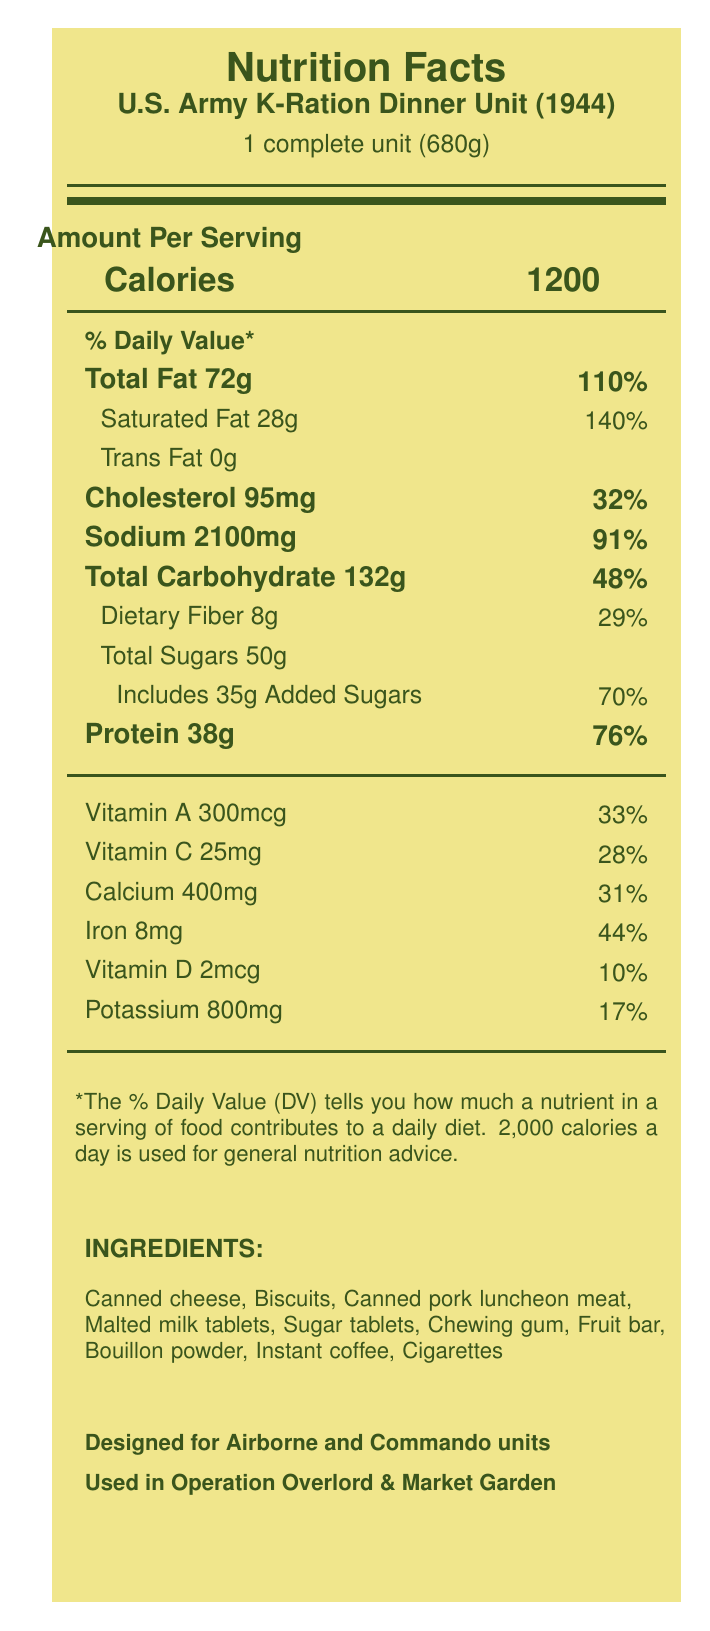what is the serving size of the U.S. Army K-Ration Dinner Unit (1944)? The serving size is listed as "1 complete unit (680g)" in the document.
Answer: 1 complete unit (680g) how many calories are in one serving of the 1944 K-Ration Dinner Unit? The document states that the calories per serving are 1200.
Answer: 1200 what is the daily value percentage for saturated fat? The document indicates that the daily value percentage for saturated fat is 140%.
Answer: 140% how much sodium is in one serving? According to the document, one serving contains 2100 milligrams of sodium.
Answer: 2100 mg what type of meat is included in the ingredients of the 1944 K-Ration Dinner Unit? The ingredient list includes "Canned pork luncheon meat."
Answer: Canned pork luncheon meat how does the sodium content in the 1944 K-Ration compare to modern MREs? A. Increased by 400 mg B. Reduced by 400 mg C. No change D. Increased by 200 mg The document mentions a sodium reduction of 400 mg when comparing to modern MREs.
Answer: B. Reduced by 400 mg which of the following vitamins and minerals have the highest daily value percentage in the 1944 K-Ration Dinner Unit? A. Vitamin A B. Vitamin C C. Calcium D. Iron Iron has the highest daily value percentage, at 44%.
Answer: D. Iron which unit of measurement is used for the amount of dietary fiber listed? A. grams B. milligrams C. micrograms D. percent daily value The unit of measurement used for dietary fiber is grams (8g).
Answer: A. grams Was the 1944 K-Ration Dinner Unit used in Operation Market Garden? The document states that the K-Ration was used in Operation Market Garden.
Answer: Yes summarize the design and usage of the 1944 K-Ration Dinner Unit in one or two sentences. The K-Ration was specifically aimed at providing compact, robust, and nutritionally adequate meals for combat troops, with usage in notable operations such as Overlord and Market Garden.
Answer: The 1944 K-Ration Dinner Unit, developed by the U.S. Army Quartermaster Corps, was designed for airborne and commando units. It featured waterproof packaging and contained items like canned cheese, pork luncheon meat, and biscuits, providing 1200 calories per serving. Who developed the 1944 K-Ration Dinner Unit? The document mentions that the K-Ration was developed by the U.S. Army Quartermaster Corps.
Answer: U.S. Army Quartermaster Corps How much vitamin C is in one serving of the 1944 K-Ration Dinner Unit? According to the document, one serving contains 25 milligrams of Vitamin C.
Answer: 25 mg Did the K-Ration Dinner Unit contain any added sugars? The document lists that the K-Ration Dinner Unit includes 35 grams of added sugars.
Answer: Yes What items have been removed from modern MREs compared to the 1944 K-Ration Dinner Unit? A. Fruit Bar B. Cigarettes C. Cheese D. Biscuits The document states that cigarettes have been removed from the modern MREs.
Answer: B. Cigarettes Can you find the total added sugars value in modern MREs from this document? The document does not provide the total added sugars value for modern MREs.
Answer: Not enough information 